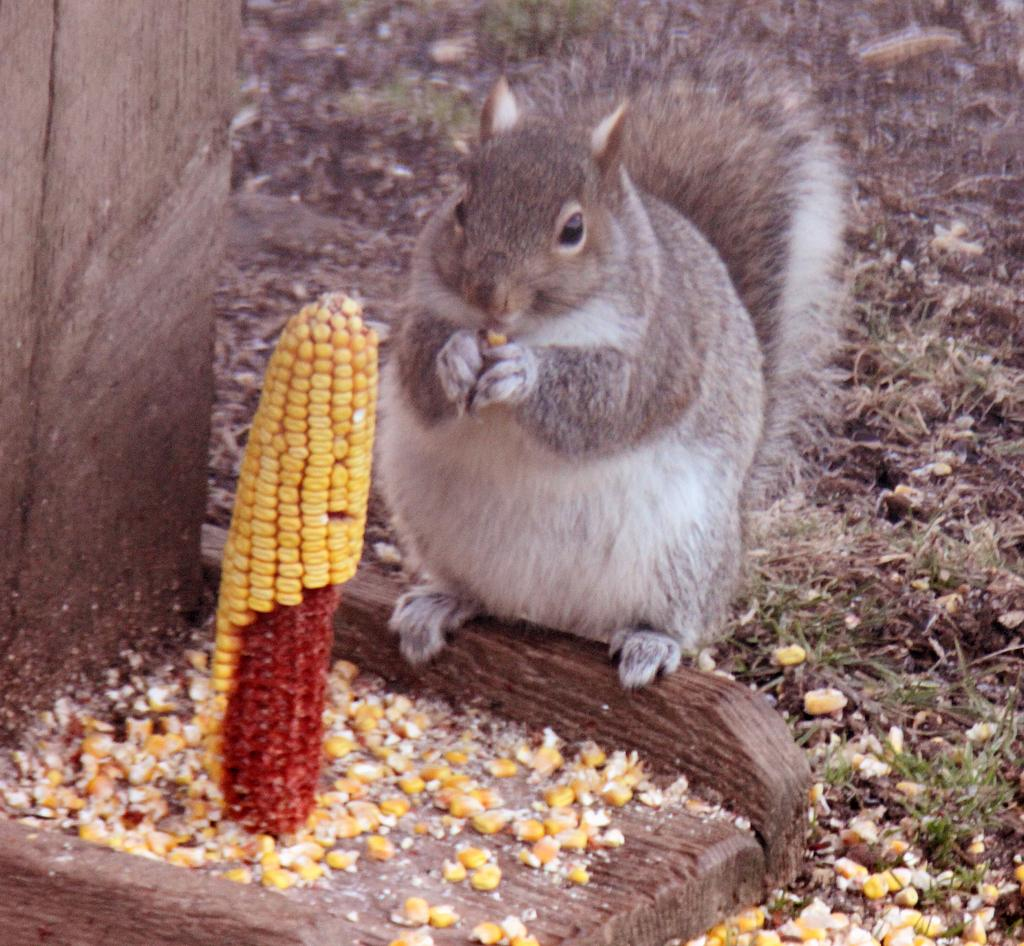What type of animal can be seen in the image? There is a squirrel in the image. What is the squirrel interacting with in the image? The squirrel is interacting with a corn in the image. What color is the grass visible on the ground? The grass is green in the image. What object can be seen on the left side of the image? There is a wooden block on the left side of the image. What grade does the squirrel receive for its performance in the image? There is no grading system or performance evaluation present in the image, as it features a squirrel interacting with a corn and green grass. 